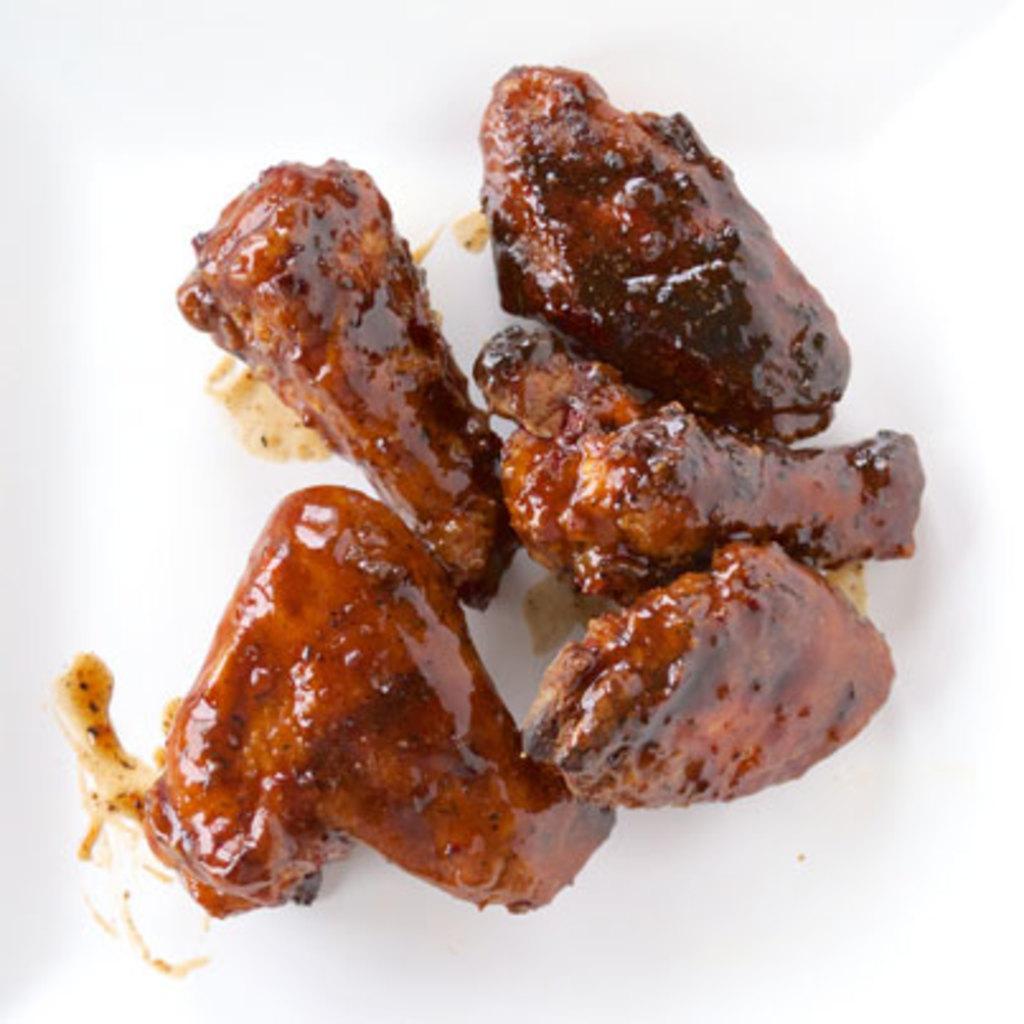Please provide a concise description of this image. Here I can see some food item. It is looking like a meat slices. 